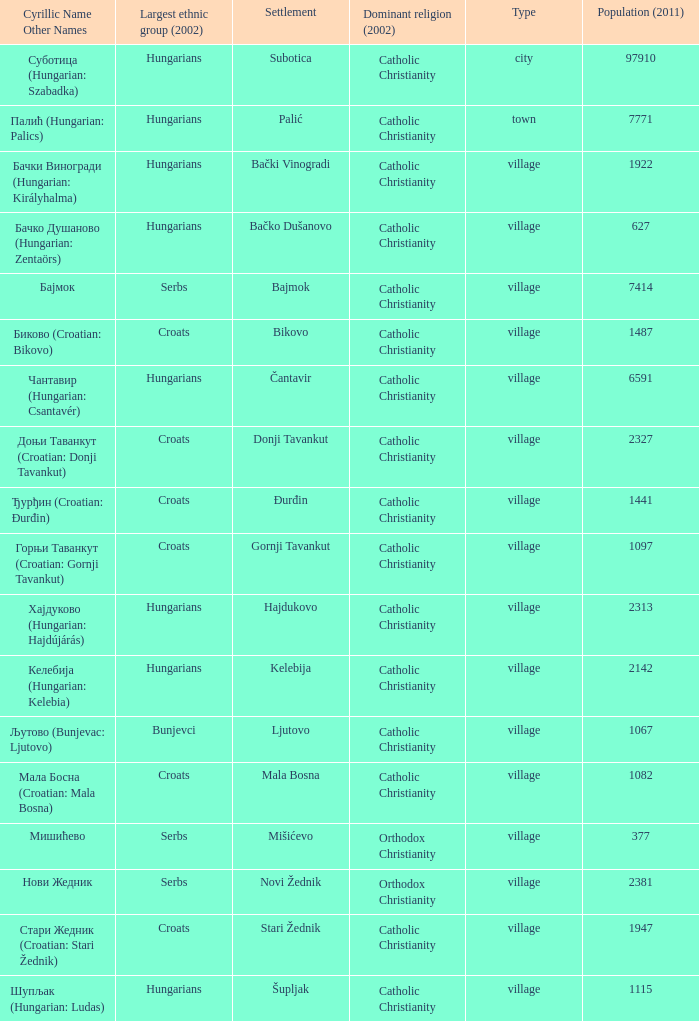What are the cyrillic and other names of the settlement whose population is 6591? Чантавир (Hungarian: Csantavér). 